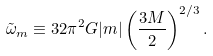<formula> <loc_0><loc_0><loc_500><loc_500>\tilde { \omega } _ { m } \equiv 3 2 \pi ^ { 2 } G | m | \left ( \frac { 3 M } { 2 } \right ) ^ { 2 / 3 } .</formula> 